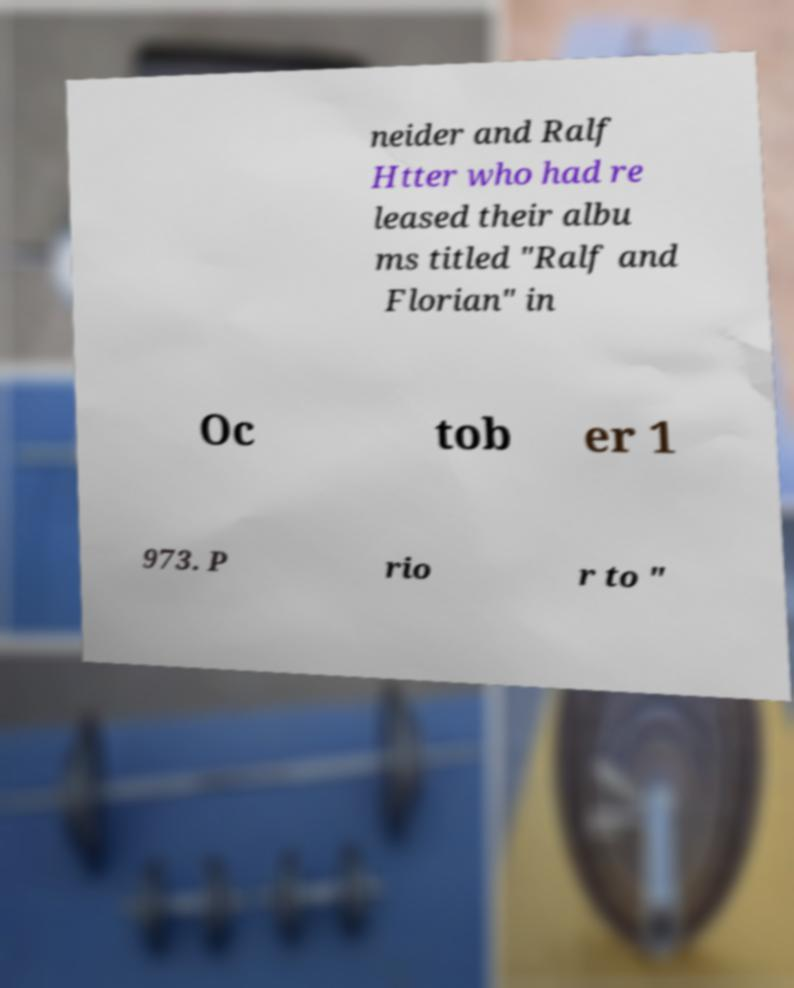Can you read and provide the text displayed in the image?This photo seems to have some interesting text. Can you extract and type it out for me? neider and Ralf Htter who had re leased their albu ms titled "Ralf and Florian" in Oc tob er 1 973. P rio r to " 